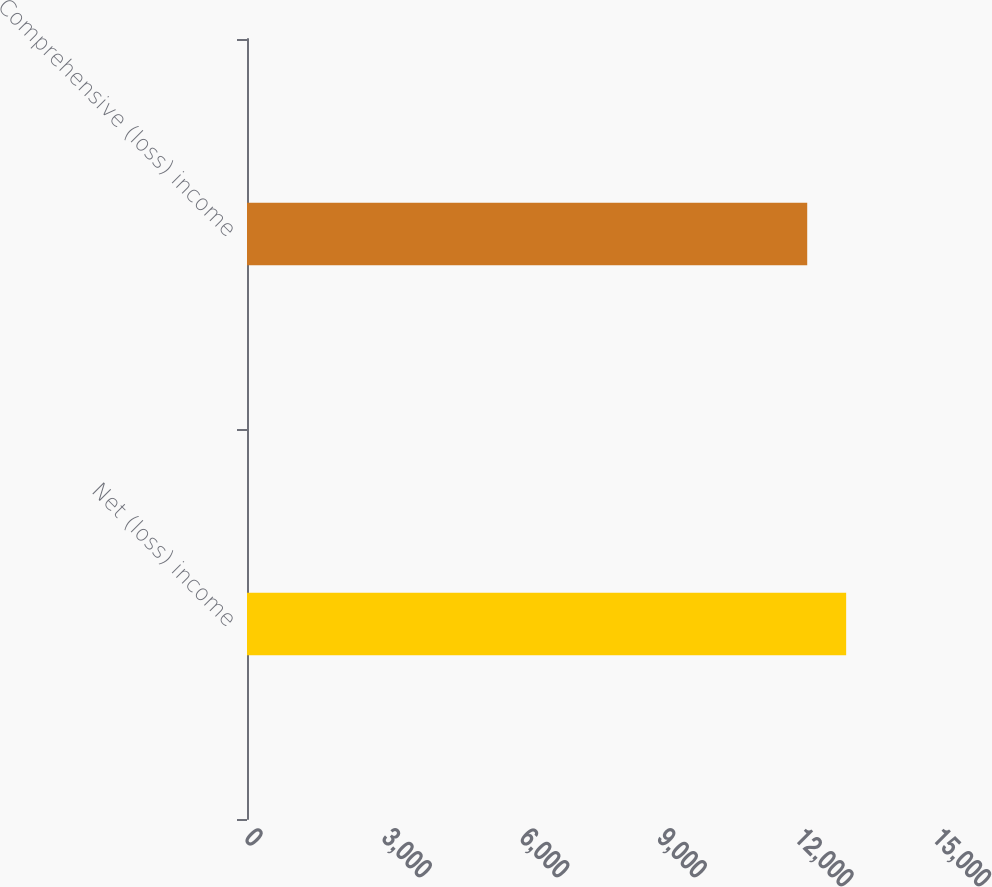Convert chart to OTSL. <chart><loc_0><loc_0><loc_500><loc_500><bar_chart><fcel>Net (loss) income<fcel>Comprehensive (loss) income<nl><fcel>13063<fcel>12214<nl></chart> 